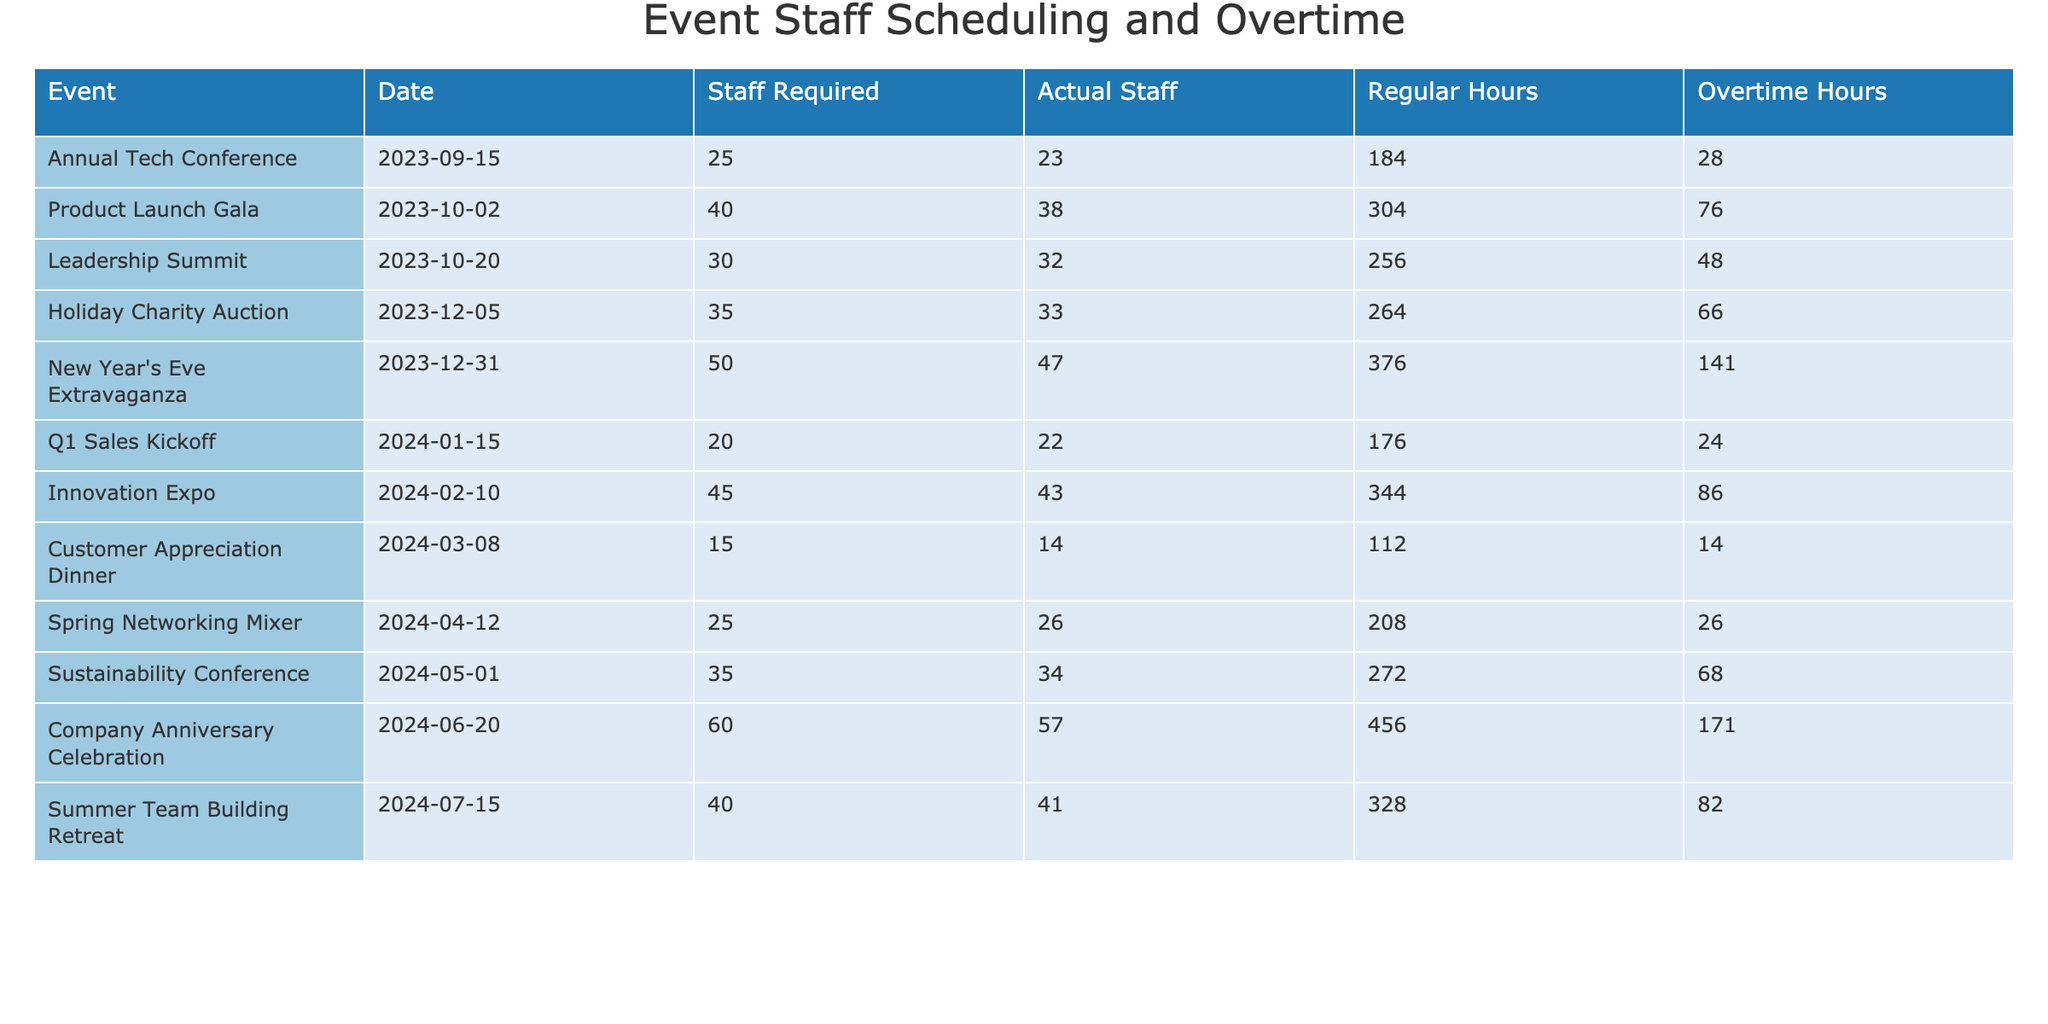What is the total number of overtime hours recorded across all events? Summing the overtime hours for all events: 28 + 76 + 48 + 66 + 141 + 24 + 86 + 14 + 26 + 68 + 171 + 82 =  960.
Answer: 960 How many events required more staff than the actual staff present? The events with more staff required than actual staff are: Annual Tech Conference, Product Launch Gala, and Holiday Charity Auction. This totals to 3 events.
Answer: 3 What was the average number of regular hours worked per event? To find the average, sum up the regular hours (184 + 304 + 256 + 264 + 376 + 176 + 344 + 112 + 208 + 272 + 456 + 328 = 2,800) and divide by the number of events (12). 2800 / 12 = 233.33.
Answer: 233.33 Did the New Year's Eve Extravaganza have the highest number of overtime hours? Comparing overtime hours, New Year's Eve Extravaganza (141) does have the highest when compared to all others: the highest is indeed 141.
Answer: Yes Which event had the largest difference between required staff and actual staff? Calculate the differences: Annual Tech Conference (2), Product Launch Gala (2), Leadership Summit (0), Holiday Charity Auction (2), New Year's Eve Extravaganza (3), Q1 Sales Kickoff (-2), Innovation Expo (2), Customer Appreciation Dinner (1), Spring Networking Mixer (-1), Sustainability Conference (1), Company Anniversary Celebration (3), Summer Team Building Retreat (-1). The maximum difference is 3 for New Year's Eve Extravaganza and Company Anniversary Celebration.
Answer: 3 What percentage of the total staff hours (regular + overtime) for the Leadership Summit were overtime hours? Calculate total staff hours: 256 (regular) + 48 (overtime) = 304; now, the percentage is (48 / 304) * 100 = 15.79%.
Answer: 15.79% What was the total staff required for events in Q4 of 2023? The events in Q4 are: Holiday Charity Auction and New Year's Eve Extravaganza. The total staff required for these events is 35 + 50 = 85.
Answer: 85 Were there more overtime hours than regular hours in any event? By checking the events, New Year's Eve Extravaganza (141 > 376), Company Anniversary Celebration (171 > 456), and others show overtime hours, indicating that these two events had more overtime than regular hours.
Answer: Yes How many events had more than 30 regular hours worked? The events with more than 30 regular hours are: Annual Tech Conference, Product Launch Gala, Leadership Summit, Holiday Charity Auction, New Year's Eve Extravaganza, Innovation Expo, Sustainability Conference, Company Anniversary Celebration, and Summer Team Building Retreat, totaling 9 events.
Answer: 9 